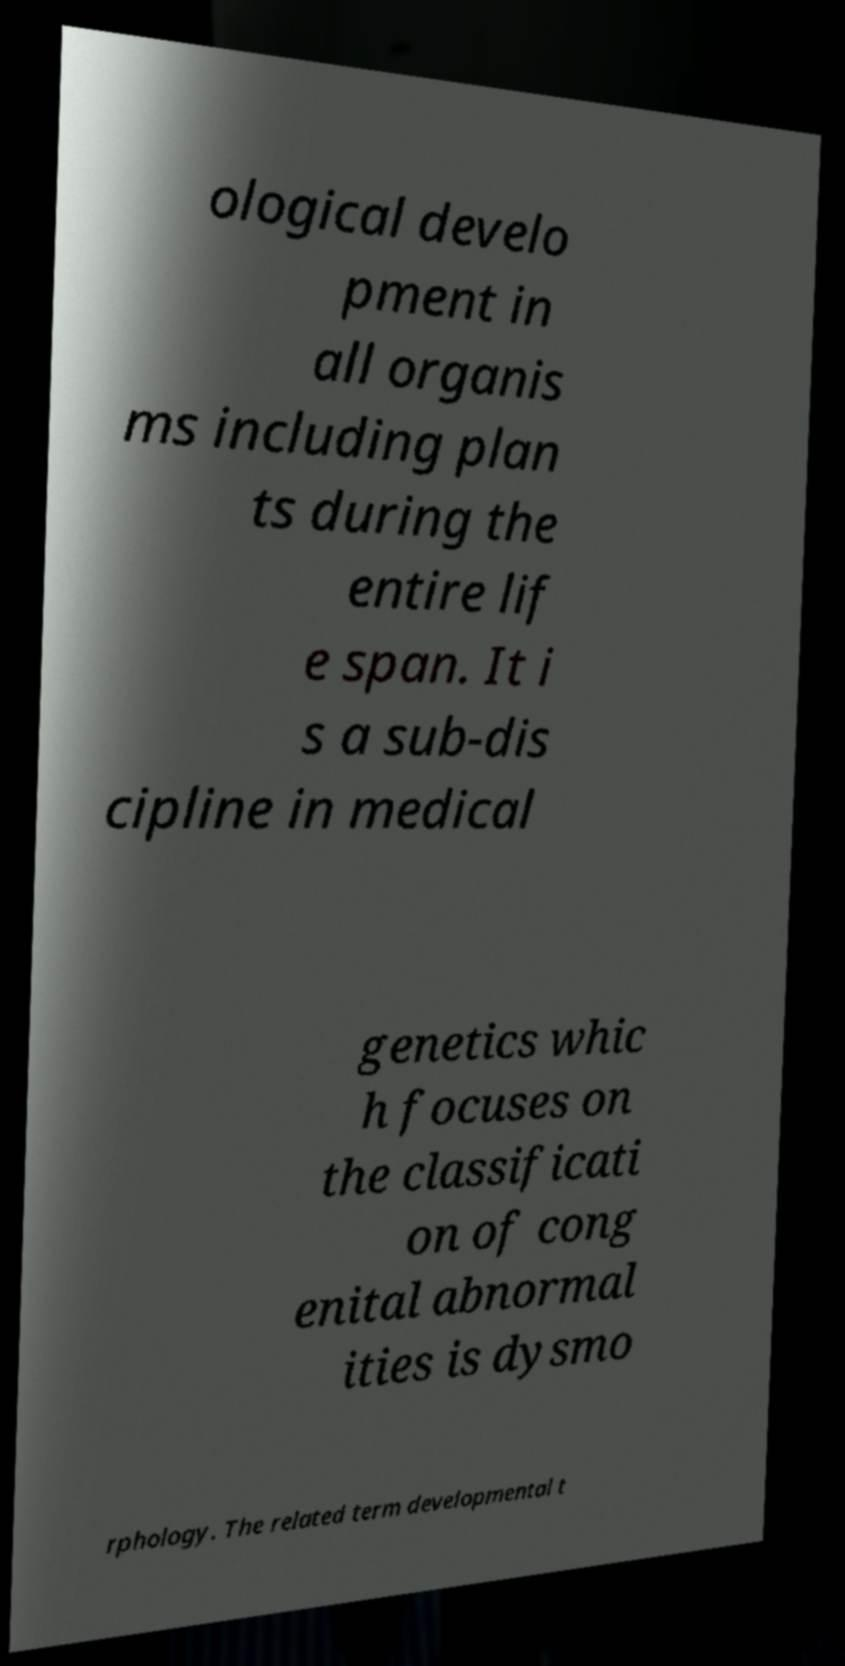Please read and relay the text visible in this image. What does it say? ological develo pment in all organis ms including plan ts during the entire lif e span. It i s a sub-dis cipline in medical genetics whic h focuses on the classificati on of cong enital abnormal ities is dysmo rphology. The related term developmental t 